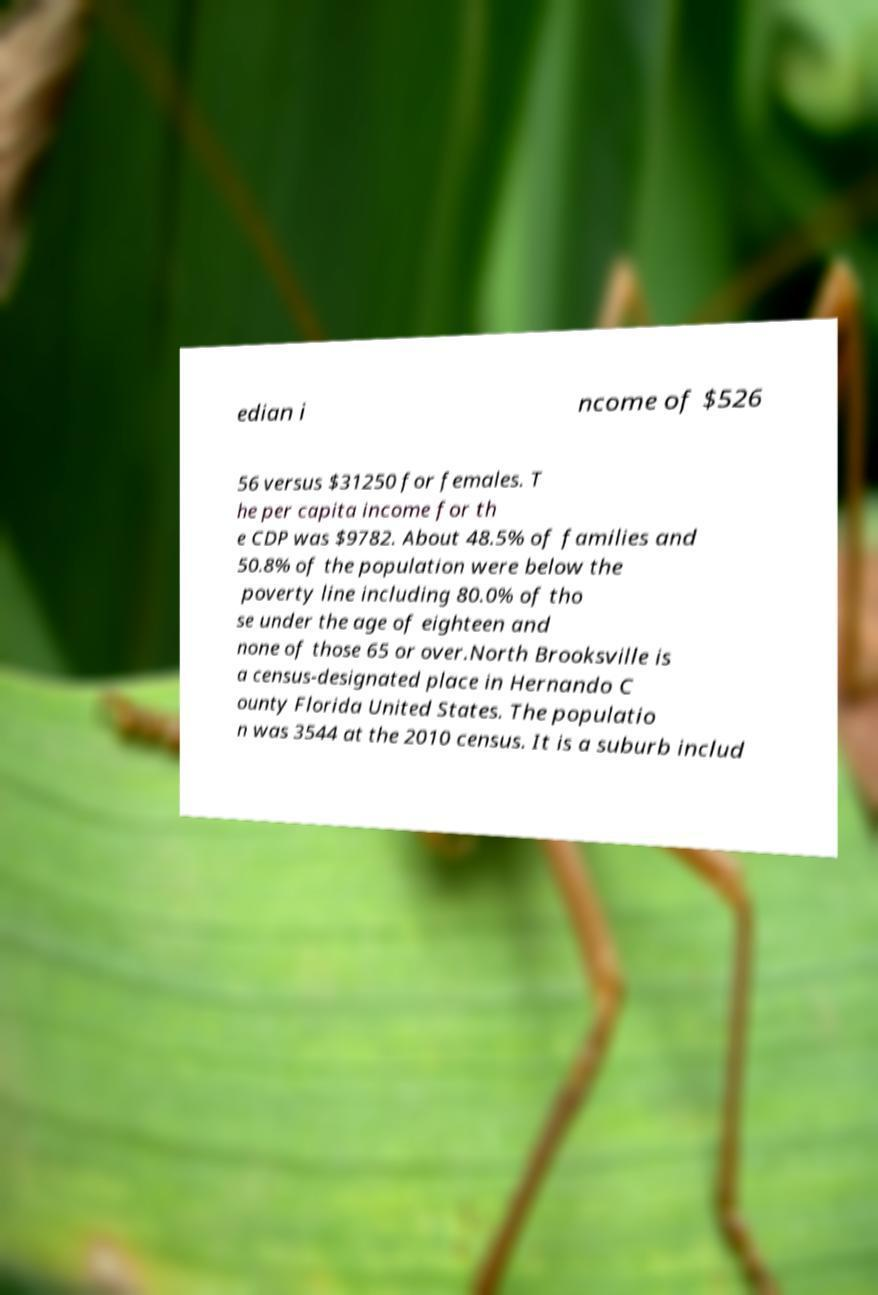I need the written content from this picture converted into text. Can you do that? edian i ncome of $526 56 versus $31250 for females. T he per capita income for th e CDP was $9782. About 48.5% of families and 50.8% of the population were below the poverty line including 80.0% of tho se under the age of eighteen and none of those 65 or over.North Brooksville is a census-designated place in Hernando C ounty Florida United States. The populatio n was 3544 at the 2010 census. It is a suburb includ 